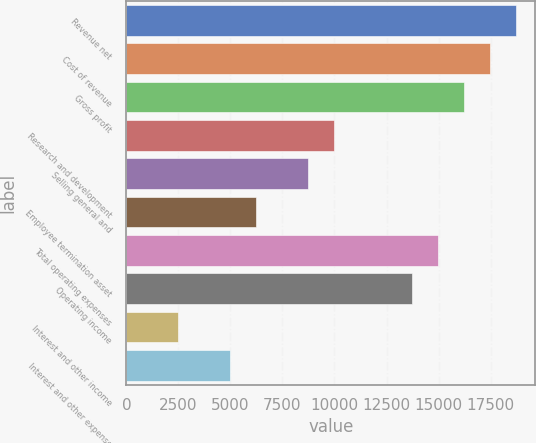<chart> <loc_0><loc_0><loc_500><loc_500><bar_chart><fcel>Revenue net<fcel>Cost of revenue<fcel>Gross profit<fcel>Research and development<fcel>Selling general and<fcel>Employee termination asset<fcel>Total operating expenses<fcel>Operating income<fcel>Interest and other income<fcel>Interest and other expense<nl><fcel>18713.7<fcel>17466.5<fcel>16219.4<fcel>9983.7<fcel>8736.56<fcel>6242.28<fcel>14972.3<fcel>13725.1<fcel>2500.86<fcel>4995.14<nl></chart> 